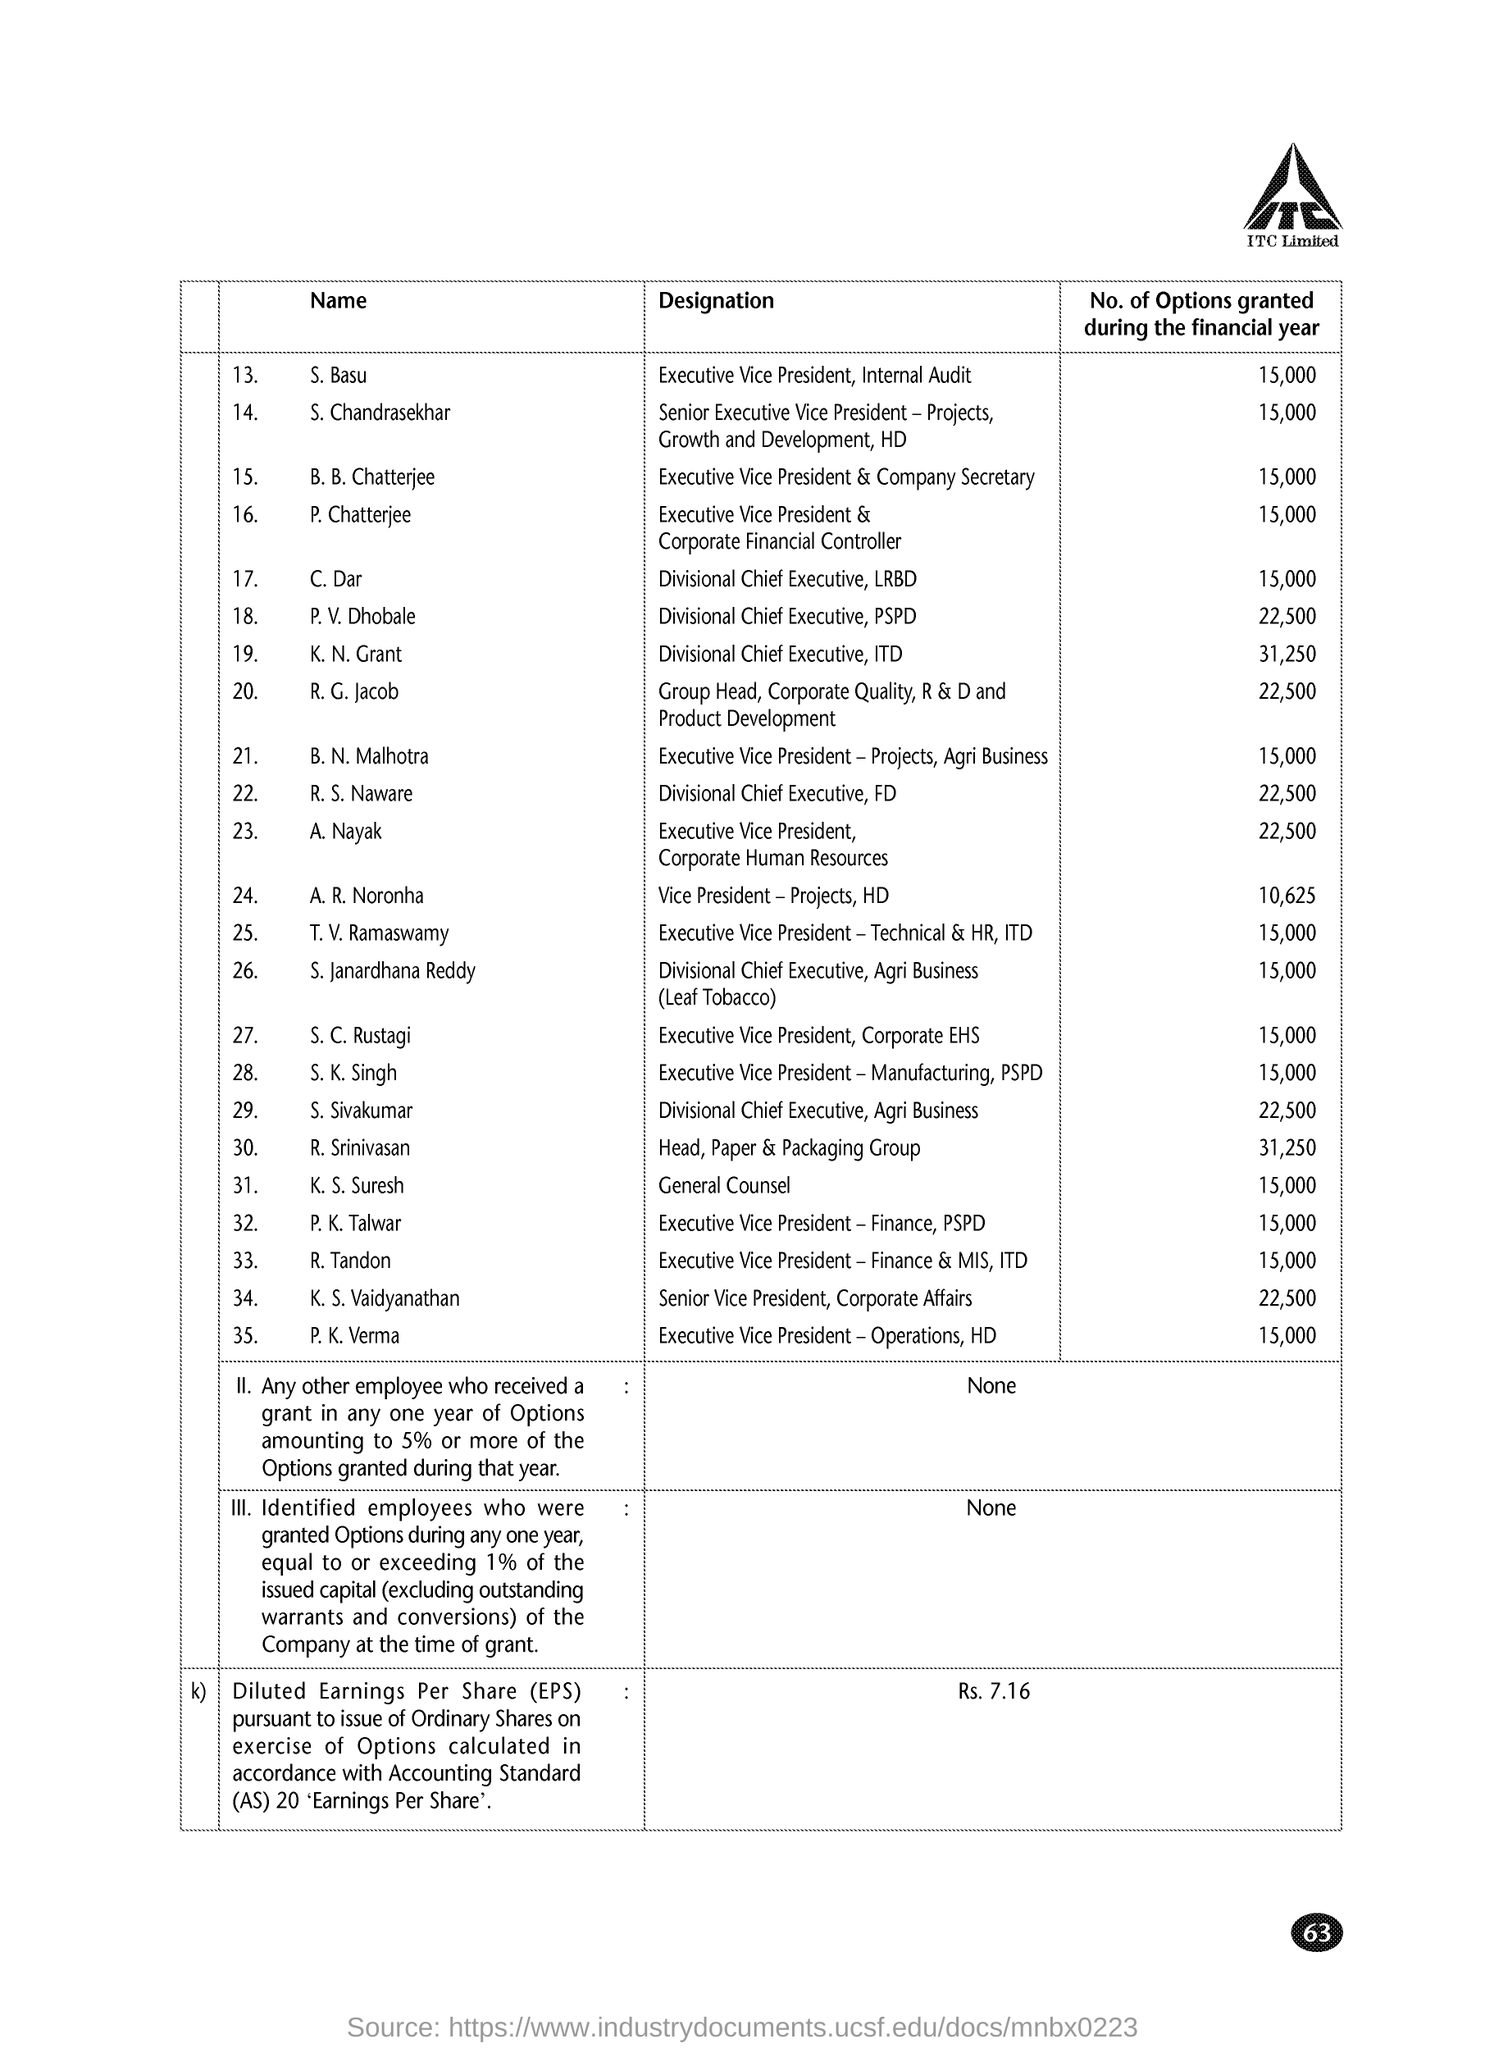Draw attention to some important aspects in this diagram. K.S.Suresh is the General Counsel. During the financial year, 15,000 options were granted to S.Chandrasekhar. The individual who holds the title of senior vice president of corporate affairs is K.S. Vaidyanathan. The executive vice president and company secretary is B.B. Chatterjee. During the financial year, a certain number of options were granted to an individual named C.Dar, which was 15,000 in total. 